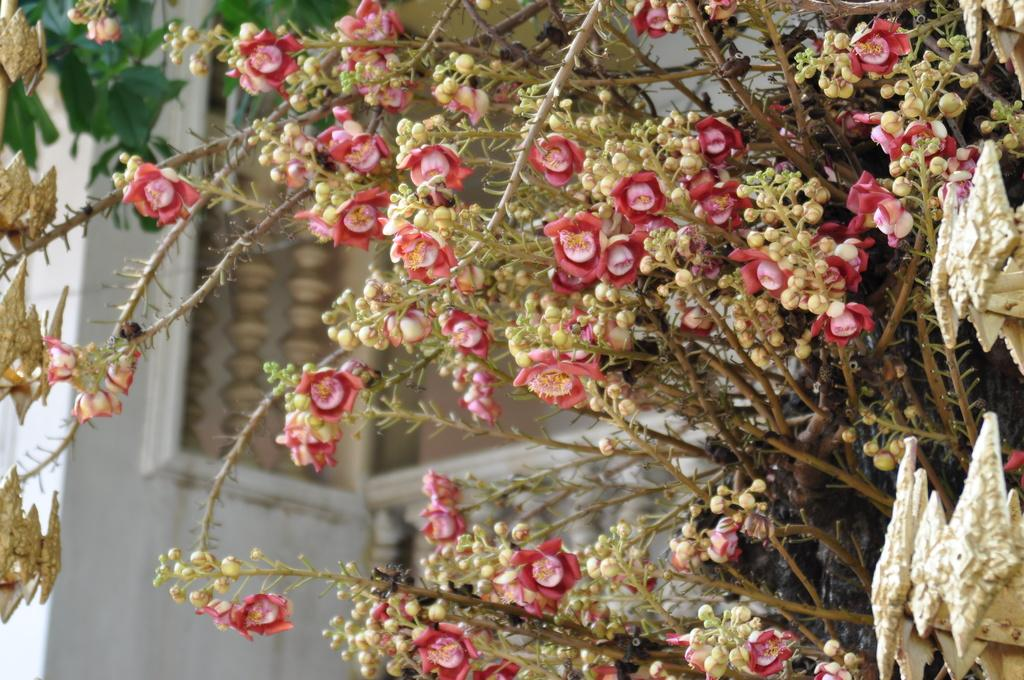What type of plants can be seen in the image? There are plants with flowers and plants with buds in the image. What is the current stage of growth for the plants with buds? The plants with buds are not yet in full bloom. What else can be seen in the image besides the plants? There are other objects in the image. What can be seen in the background of the image? There is a wall visible in the background of the image. How many children are playing on the dock in the image? There are no children or docks present in the image. 